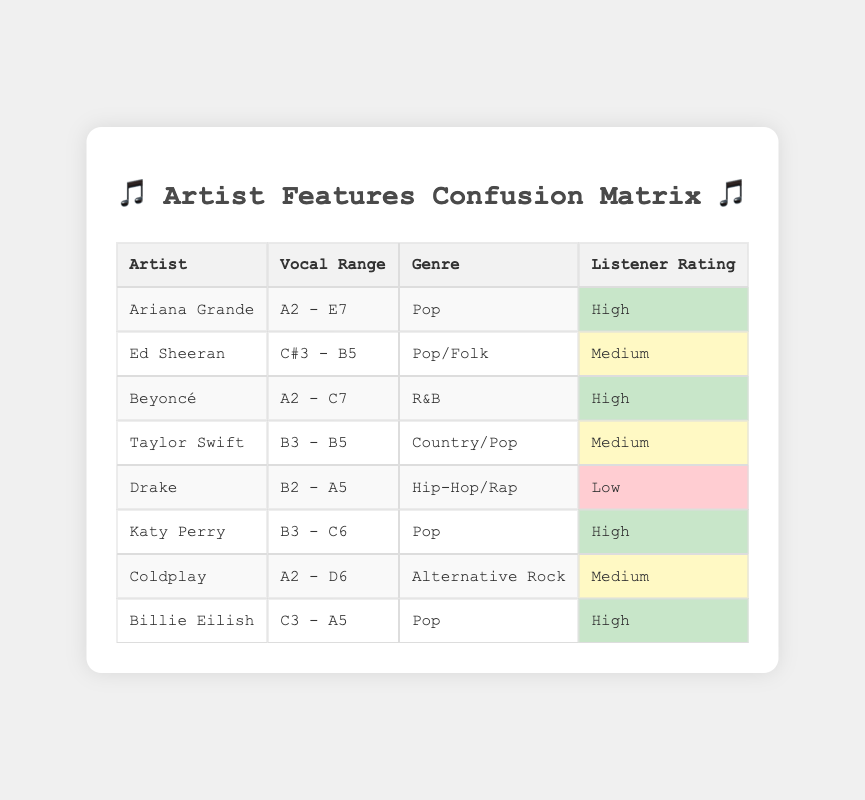What is the vocal range of Ariana Grande? Ariana Grande's vocal range is specified in the table under the column "Vocal Range," which shows it as 'A2 - E7.'
Answer: A2 - E7 Which artist has the lowest listener rating? By examining the "Listener Rating" column, we can see that Drake has a rating of 'Low,' which is the lowest among all the artists listed.
Answer: Drake How many artists have a high listener rating? The table shows three artists ('Ariana Grande,' 'Beyoncé,' 'Katy Perry,' and 'Billie Eilish') with the rating of 'High.' Counting these gives us 4 artists.
Answer: 4 Is Ed Sheeran categorized as a Pop artist? In the table, Ed Sheeran is categorized under the "Genre" column as 'Pop/Folk.' Since Pop is one of the genres listed, the answer is yes.
Answer: Yes What genre does Taylor Swift belong to? Referring to the "Genre" column in the table, Taylor Swift is categorized as 'Country/Pop.'
Answer: Country/Pop What is the average listener rating based on the categories? There are 8 artists with ratings categorized as 'High' (4), 'Medium' (3), and 'Low' (1). Assigning numerical values (High=3, Medium=2, Low=1), the average rating = (3*4 + 2*3 + 1*1) / 8 = (12 + 6 + 1) / 8 = 19 / 8 = 2.375, which rounds to Medium.
Answer: Medium Which artist has a vocal range that includes 'C7'? Scanning through the "Vocal Range" column, only Beyoncé has a vocal range that includes 'C7' (A2 - C7).
Answer: Beyoncé Is there any artist with a medium listener rating who belongs to the Pop genre? Reviewing the rows, Ed Sheeran and Taylor Swift both have a listener rating of 'Medium' but only Ed Sheeran belongs to the Pop genre.
Answer: Yes 